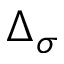Convert formula to latex. <formula><loc_0><loc_0><loc_500><loc_500>\Delta _ { \sigma }</formula> 